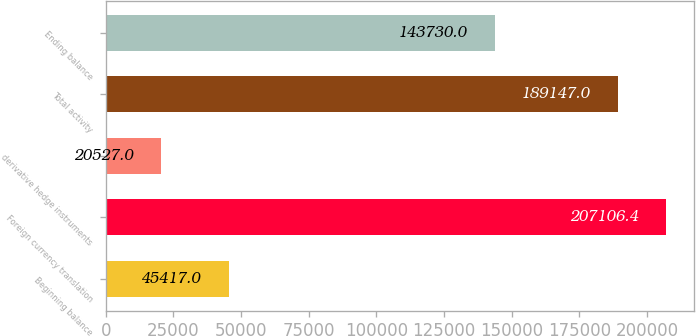<chart> <loc_0><loc_0><loc_500><loc_500><bar_chart><fcel>Beginning balance<fcel>Foreign currency translation<fcel>derivative hedge instruments<fcel>Total activity<fcel>Ending balance<nl><fcel>45417<fcel>207106<fcel>20527<fcel>189147<fcel>143730<nl></chart> 